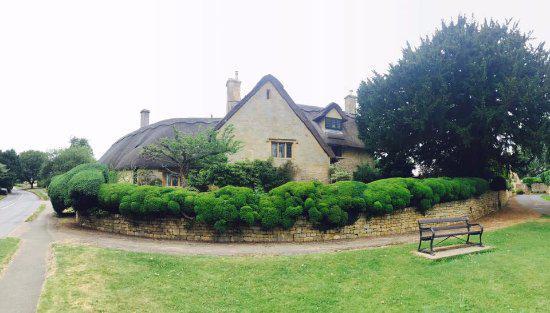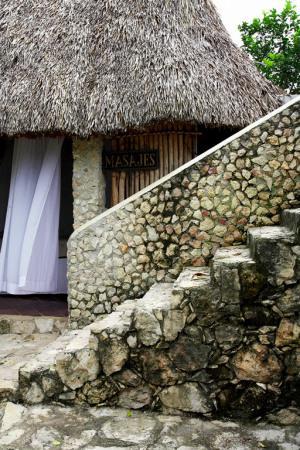The first image is the image on the left, the second image is the image on the right. Examine the images to the left and right. Is the description "The right image shows a left-facing home with two chimneys on a roof that forms at least one overhanging arch over a window." accurate? Answer yes or no. No. The first image is the image on the left, the second image is the image on the right. For the images displayed, is the sentence "In at least one image there is a house with a rounded roof and two chimney." factually correct? Answer yes or no. Yes. 